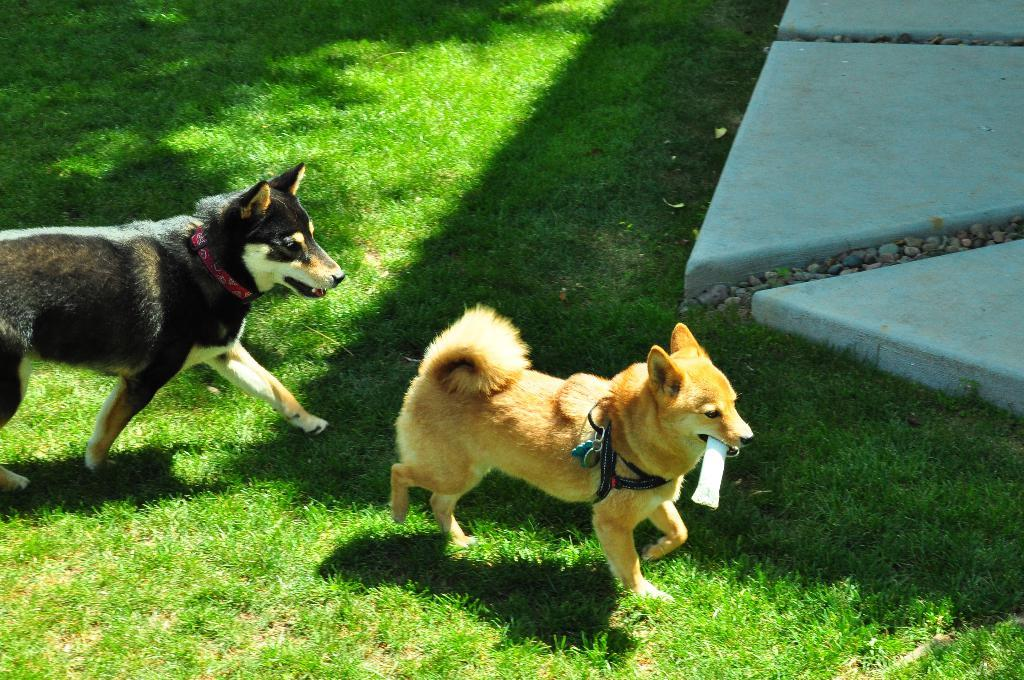How many dogs are present in the image? There are two dogs in the image. What are the dogs doing in the image? The dogs are walking on the ground. Can you describe what one of the dogs is carrying in its mouth? One of the dogs is holding something in its mouth. What type of surface can be seen under the dogs' feet? There is a marble ground in the image. What other elements can be seen in the image? There are stones visible in the image. Where is the calculator located in the image? There is no calculator present in the image. What type of fruit is the dog holding in its mouth? The dog is not holding a fruit in its mouth; it is holding something else, as mentioned in the facts. 